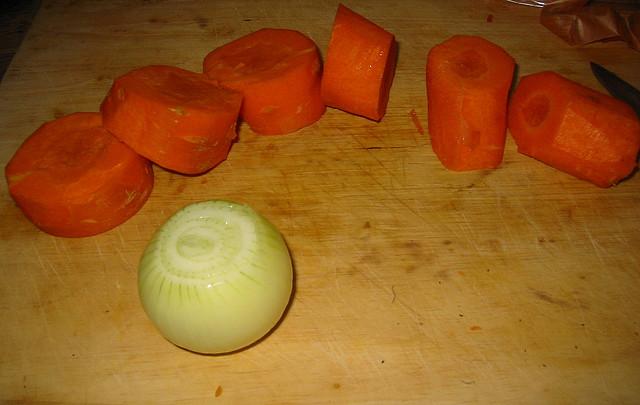What are the ingredients?
Short answer required. Carrots and onions. What kind of carrots are shown?
Write a very short answer. Orange. What is a reaction some people have when cutting onions?
Be succinct. Crying. What other ingredients besides the carrots and onion go in the beef stew?
Be succinct. Beef. Is there an apple?
Quick response, please. No. 